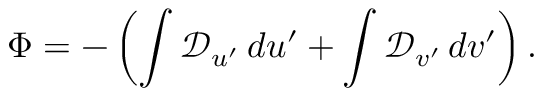<formula> <loc_0><loc_0><loc_500><loc_500>\Phi = - \left ( \int \mathcal { D } _ { u ^ { \prime } } \, d u ^ { \prime } + \int \mathcal { D } _ { v ^ { \prime } } \, d v ^ { \prime } \right ) .</formula> 